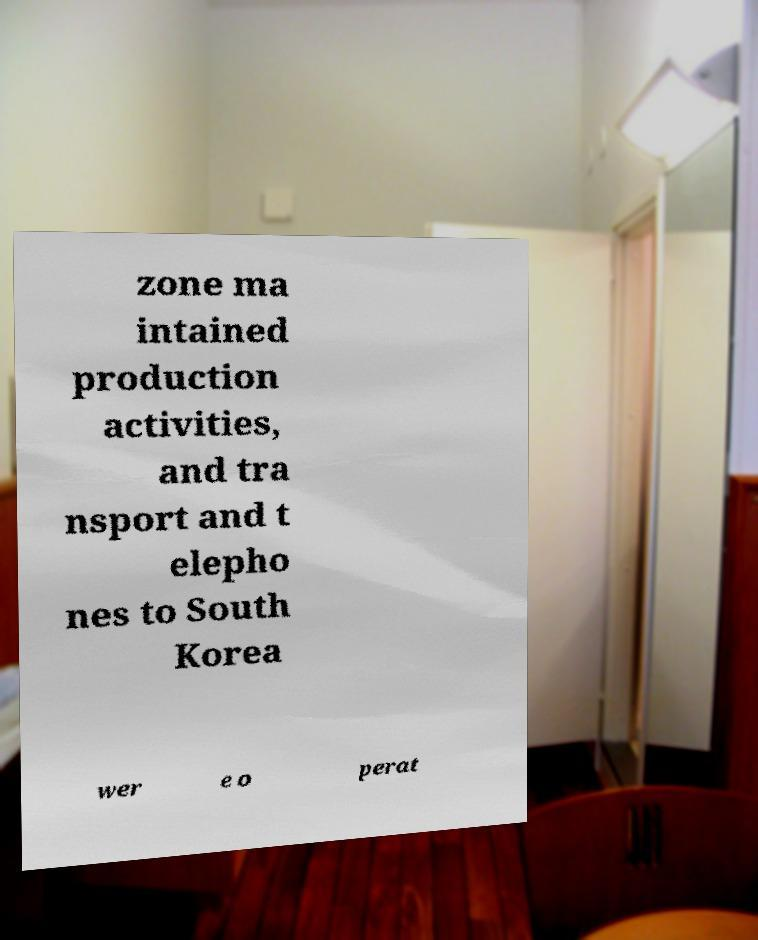Could you extract and type out the text from this image? zone ma intained production activities, and tra nsport and t elepho nes to South Korea wer e o perat 